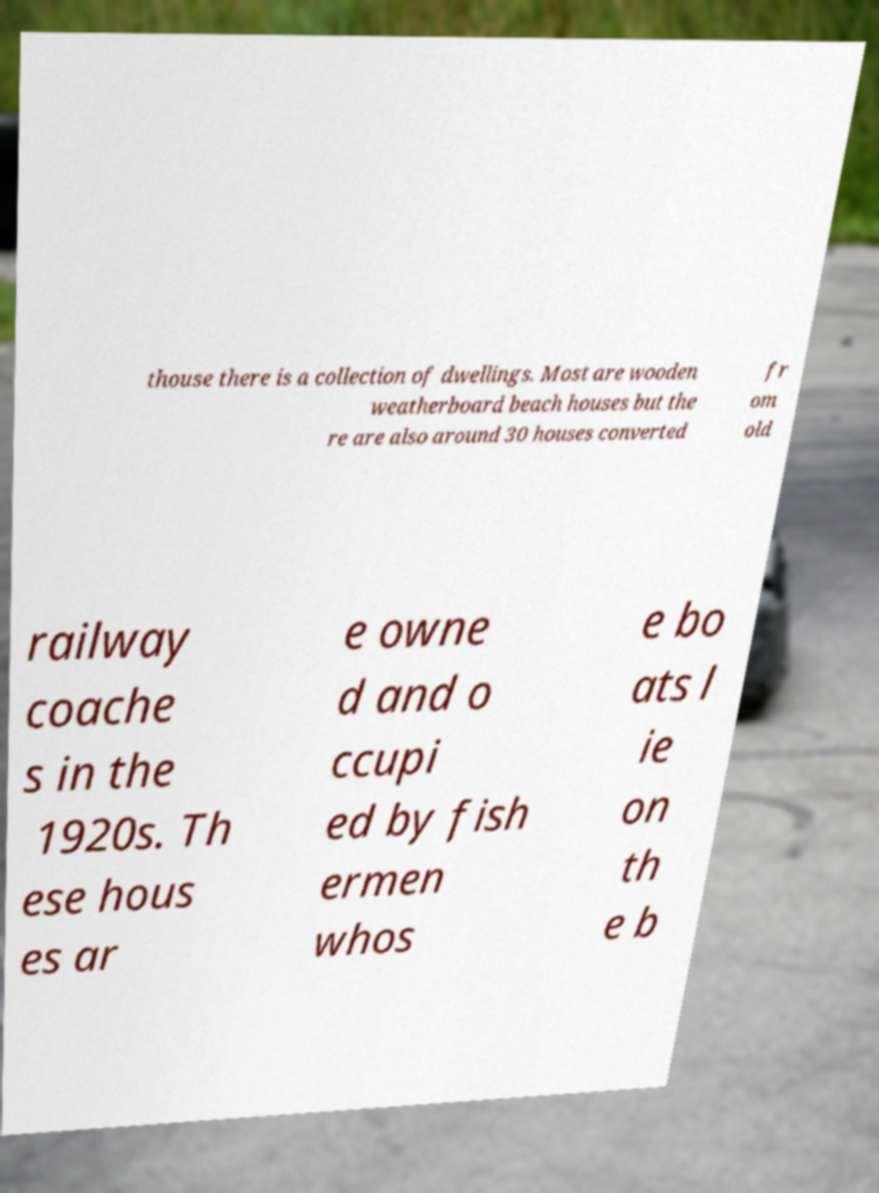Please identify and transcribe the text found in this image. thouse there is a collection of dwellings. Most are wooden weatherboard beach houses but the re are also around 30 houses converted fr om old railway coache s in the 1920s. Th ese hous es ar e owne d and o ccupi ed by fish ermen whos e bo ats l ie on th e b 